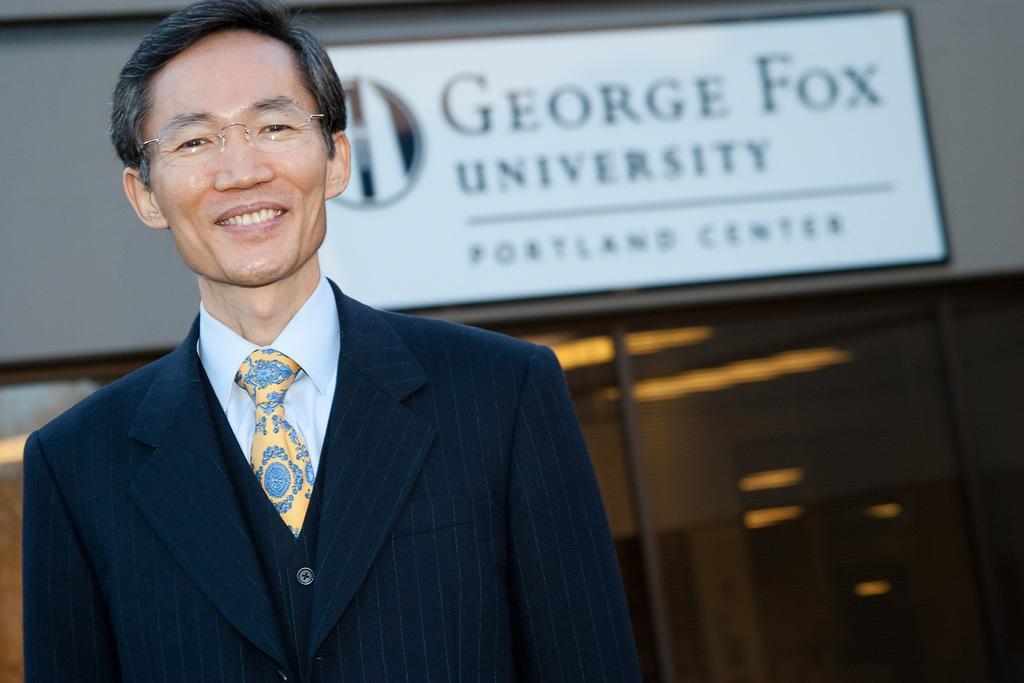Please provide a concise description of this image. In this image we can see a man. He is wearing dark blue color coat, white color shirt, yellow color tie, specks and he is smiling. Background of the image board is there on the wall. 